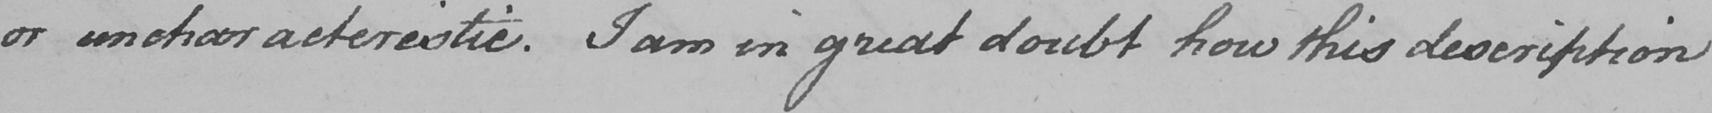Transcribe the text shown in this historical manuscript line. or uncharacteristic . I am in great doubt how this description 